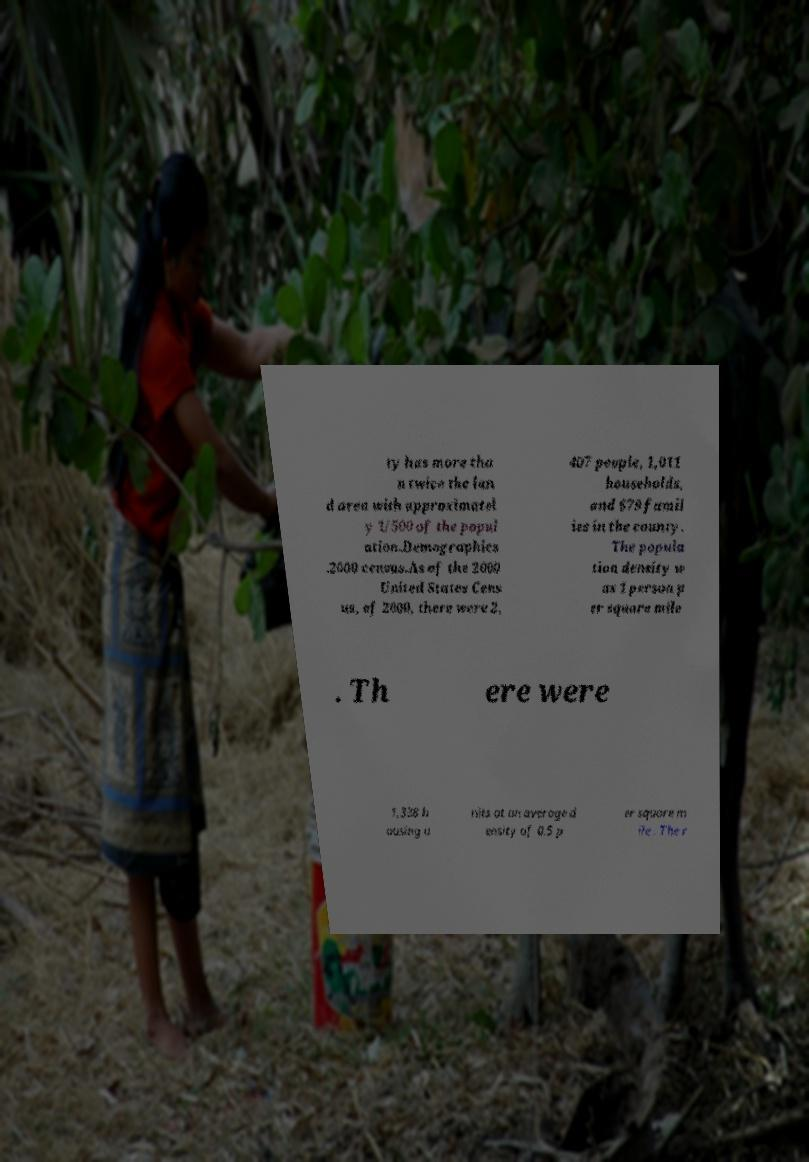Can you read and provide the text displayed in the image?This photo seems to have some interesting text. Can you extract and type it out for me? ty has more tha n twice the lan d area with approximatel y 1/500 of the popul ation.Demographics .2000 census.As of the 2000 United States Cens us, of 2000, there were 2, 407 people, 1,011 households, and 679 famil ies in the county. The popula tion density w as 1 person p er square mile . Th ere were 1,338 h ousing u nits at an average d ensity of 0.5 p er square m ile . The r 